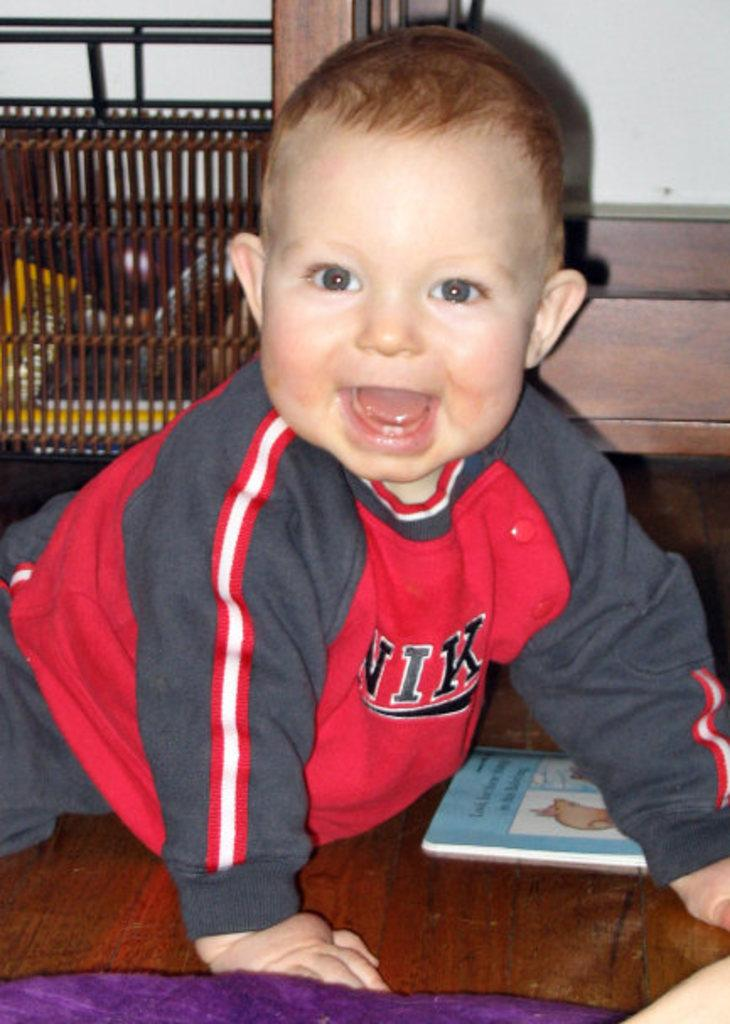<image>
Summarize the visual content of the image. A young child wears a shirt that says NIK on the front. 